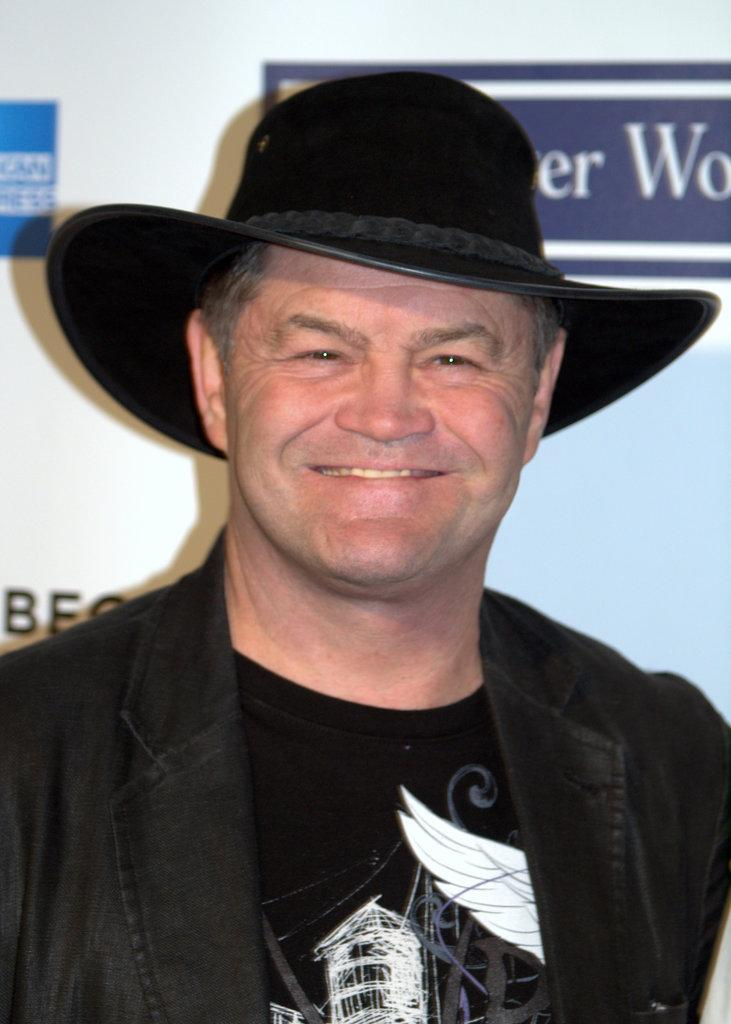What is the main subject in the foreground of the image? There is a man in the foreground of the image. What is the man wearing on his head? The man is wearing a hat. What expression does the man have on his face? The man is smiling. What can be seen in the background of the image? There is some text in the background of the image. What color is the crayon the man is holding in the image? There is no crayon present in the image; the man is not holding any object. What is the man's interest in the image? The provided facts do not mention the man's interests, so we cannot determine his interest from the image. 